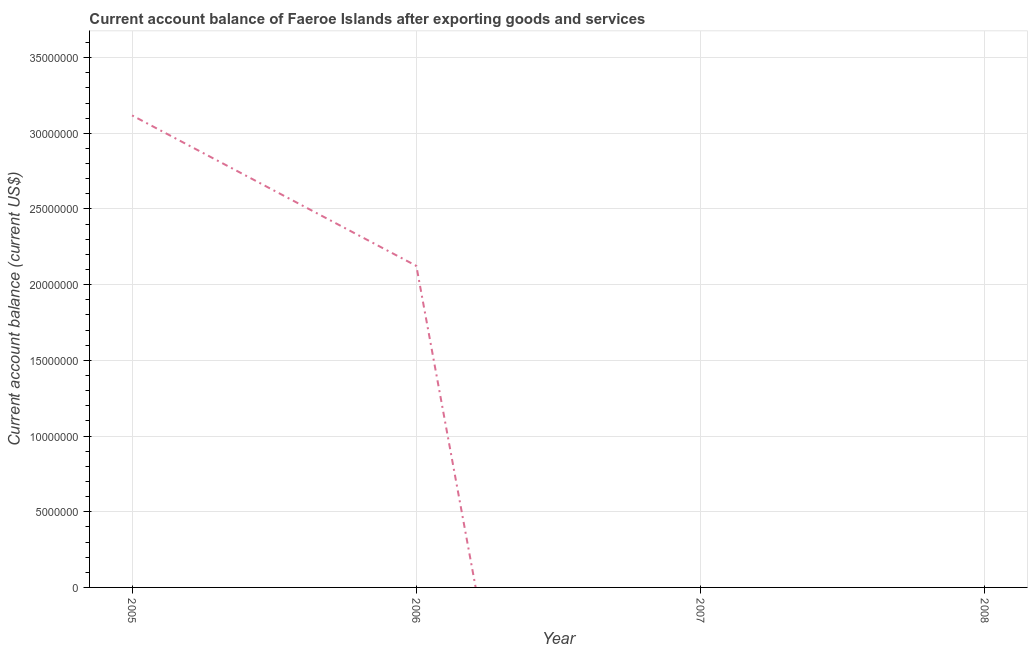What is the current account balance in 2006?
Your answer should be very brief. 2.12e+07. Across all years, what is the maximum current account balance?
Provide a short and direct response. 3.12e+07. What is the sum of the current account balance?
Ensure brevity in your answer.  5.24e+07. What is the difference between the current account balance in 2005 and 2006?
Offer a very short reply. 9.94e+06. What is the average current account balance per year?
Provide a short and direct response. 1.31e+07. What is the median current account balance?
Provide a short and direct response. 1.06e+07. In how many years, is the current account balance greater than 16000000 US$?
Ensure brevity in your answer.  2. Is the sum of the current account balance in 2005 and 2006 greater than the maximum current account balance across all years?
Offer a terse response. Yes. What is the difference between the highest and the lowest current account balance?
Your answer should be compact. 3.12e+07. Does the current account balance monotonically increase over the years?
Provide a short and direct response. No. How many lines are there?
Your answer should be very brief. 1. What is the difference between two consecutive major ticks on the Y-axis?
Your answer should be compact. 5.00e+06. Are the values on the major ticks of Y-axis written in scientific E-notation?
Provide a succinct answer. No. Does the graph contain any zero values?
Provide a short and direct response. Yes. What is the title of the graph?
Give a very brief answer. Current account balance of Faeroe Islands after exporting goods and services. What is the label or title of the X-axis?
Your answer should be compact. Year. What is the label or title of the Y-axis?
Offer a very short reply. Current account balance (current US$). What is the Current account balance (current US$) of 2005?
Your response must be concise. 3.12e+07. What is the Current account balance (current US$) of 2006?
Offer a terse response. 2.12e+07. What is the Current account balance (current US$) in 2007?
Give a very brief answer. 0. What is the Current account balance (current US$) in 2008?
Your response must be concise. 0. What is the difference between the Current account balance (current US$) in 2005 and 2006?
Make the answer very short. 9.94e+06. What is the ratio of the Current account balance (current US$) in 2005 to that in 2006?
Your answer should be compact. 1.47. 